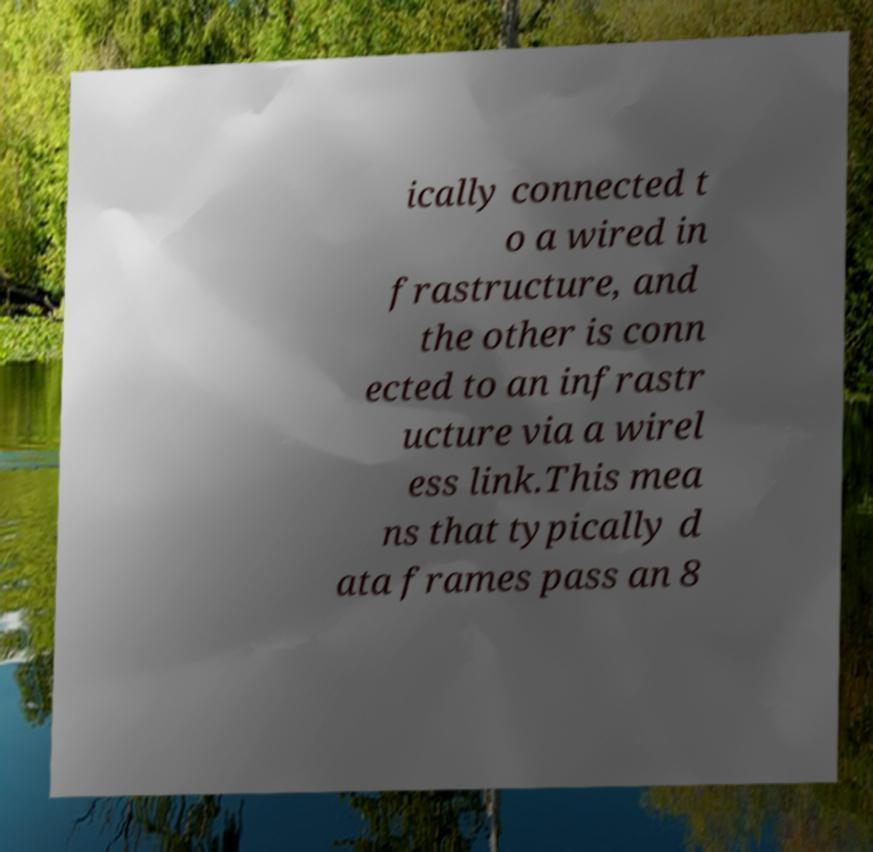Could you extract and type out the text from this image? ically connected t o a wired in frastructure, and the other is conn ected to an infrastr ucture via a wirel ess link.This mea ns that typically d ata frames pass an 8 